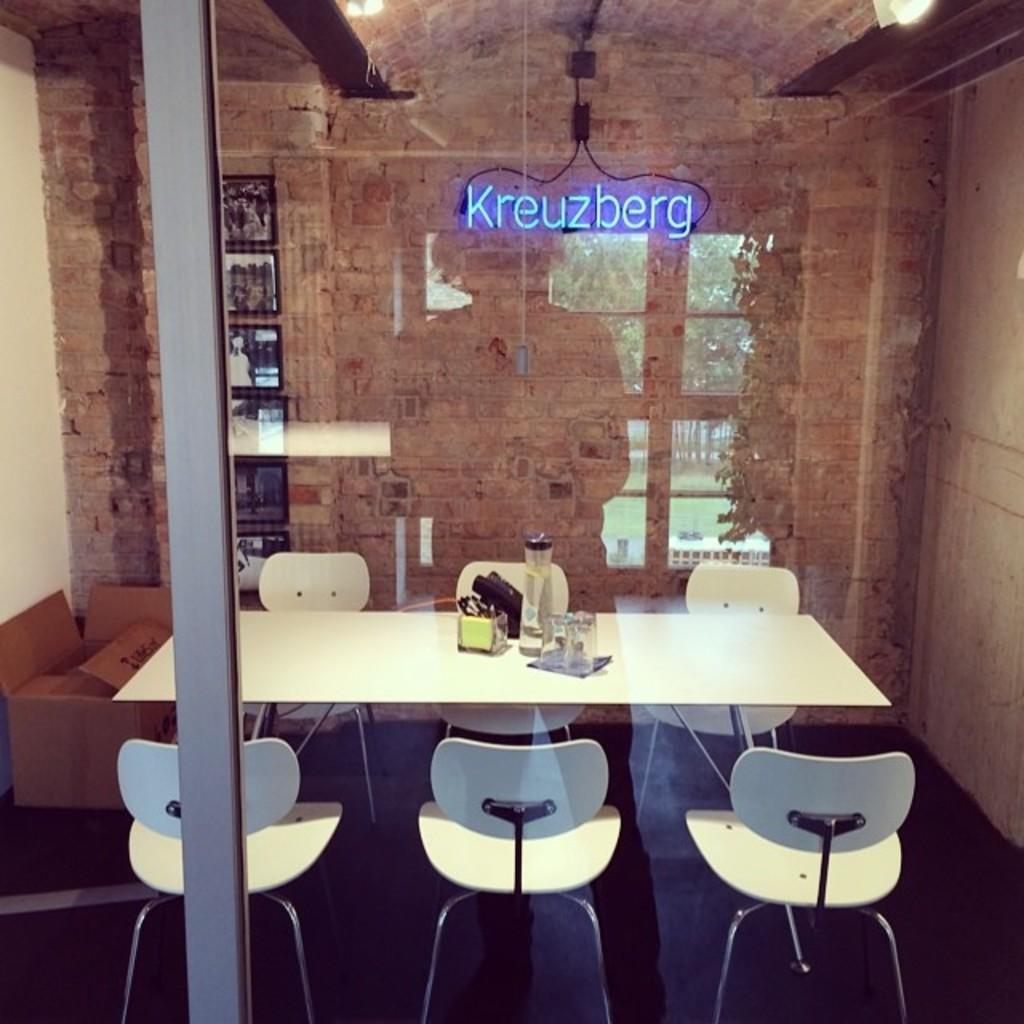What type of furniture is present in the image? There are chairs and a table in the image. What is on top of the table? There are objects on top of the table. What can be seen on the wall in the image? There is a wall with a name in the image. What type of door is visible in the image? There is a glass door in the image. What type of ship can be seen sailing in the background of the image? There is no ship visible in the image; it only features chairs, a table, objects on the table, a wall with a name, and a glass door. 